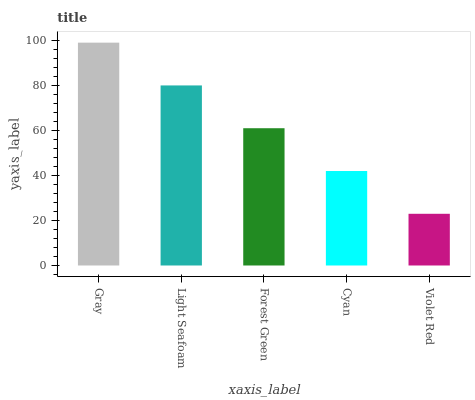Is Violet Red the minimum?
Answer yes or no. Yes. Is Gray the maximum?
Answer yes or no. Yes. Is Light Seafoam the minimum?
Answer yes or no. No. Is Light Seafoam the maximum?
Answer yes or no. No. Is Gray greater than Light Seafoam?
Answer yes or no. Yes. Is Light Seafoam less than Gray?
Answer yes or no. Yes. Is Light Seafoam greater than Gray?
Answer yes or no. No. Is Gray less than Light Seafoam?
Answer yes or no. No. Is Forest Green the high median?
Answer yes or no. Yes. Is Forest Green the low median?
Answer yes or no. Yes. Is Cyan the high median?
Answer yes or no. No. Is Violet Red the low median?
Answer yes or no. No. 